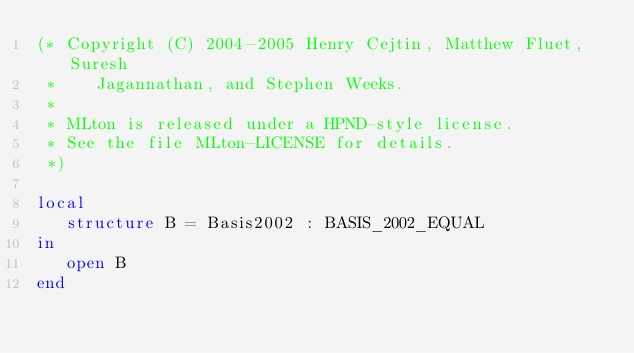<code> <loc_0><loc_0><loc_500><loc_500><_SML_>(* Copyright (C) 2004-2005 Henry Cejtin, Matthew Fluet, Suresh
 *    Jagannathan, and Stephen Weeks.
 *
 * MLton is released under a HPND-style license.
 * See the file MLton-LICENSE for details.
 *)

local
   structure B = Basis2002 : BASIS_2002_EQUAL
in
   open B
end
</code> 